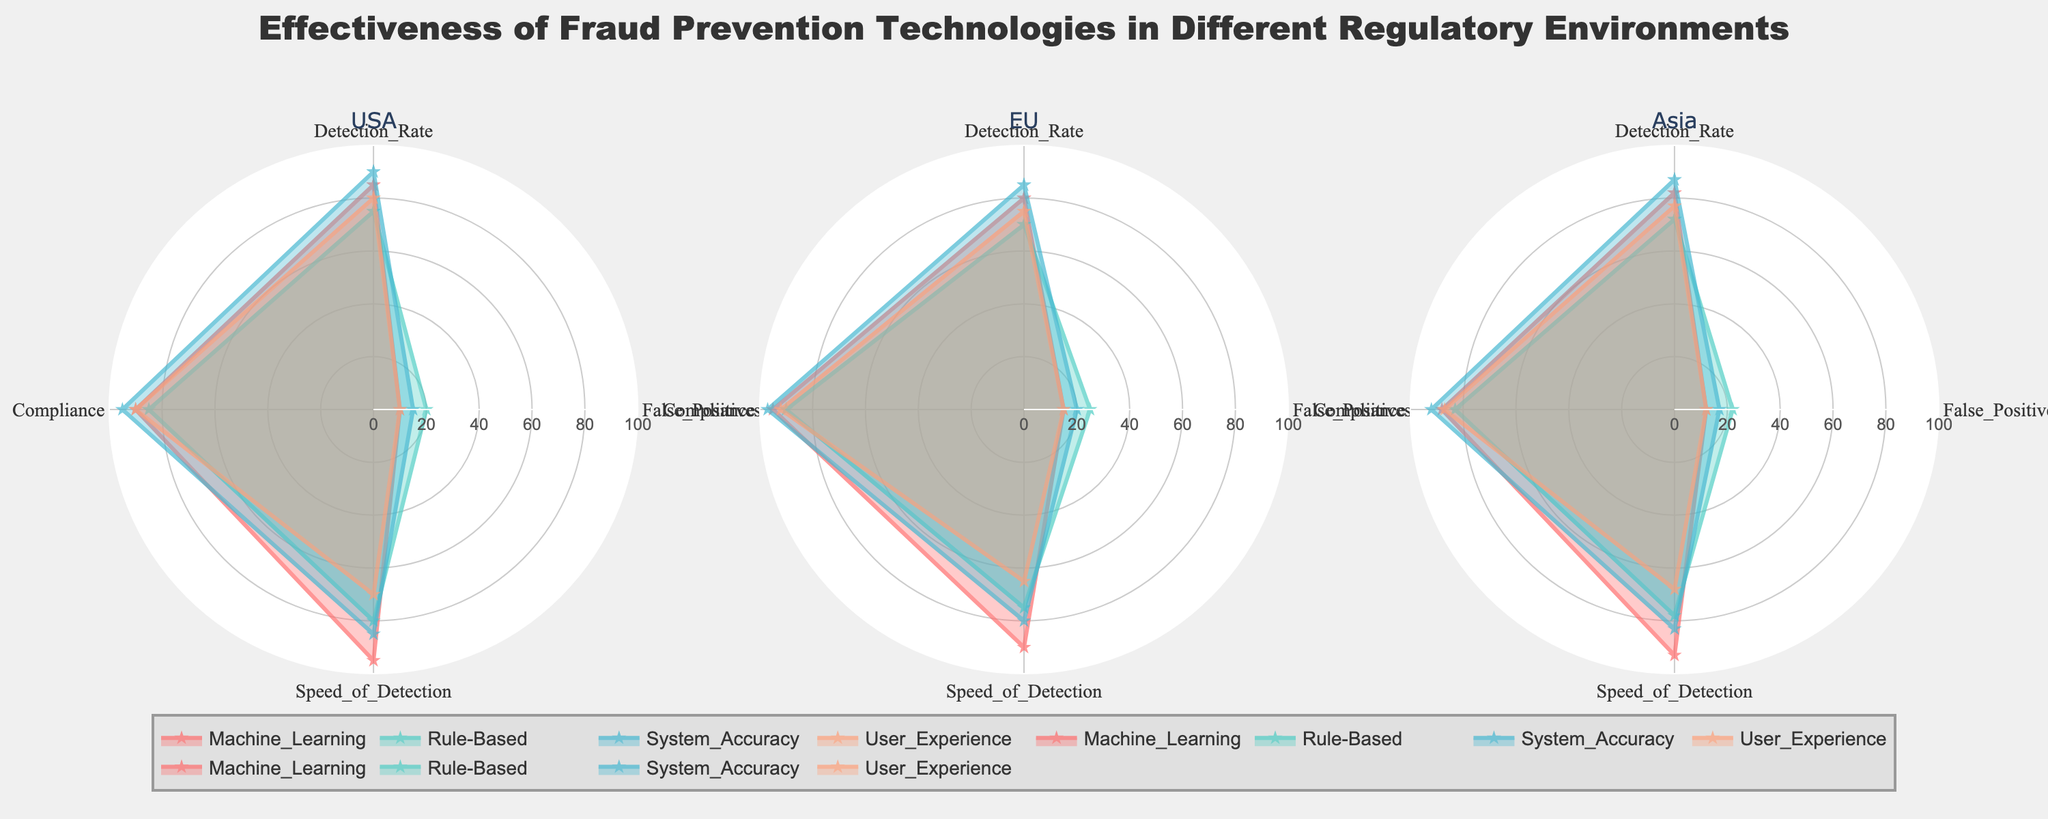What is the title of the plot? The title is displayed at the top of the plot and reads "Effectiveness of Fraud Prevention Technologies in Different Regulatory Environments".
Answer: Effectiveness of Fraud Prevention Technologies in Different Regulatory Environments How many subplots are in the figure, and what do they represent? The figure contains three subplots, each representing a different regulatory environment: USA, EU, and Asia.
Answer: Three subplots (USA, EU, Asia) Which regulatory environment has the highest detection rate for Machine Learning? Look at the detection rate for Machine Learning in all three regulatory environments. The USA has a detection rate of 85, EU has 80, and Asia has 82; thus, the USA has the highest detection rate for Machine Learning.
Answer: USA For the EU regulatory environment, what is the false positive rate for Rule-Based fraud prevention technology? In the EU subplot, the radar chart for the Rule-Based technology shows a false positive rate of 25.
Answer: 25 Which technology has the best user experience in the USA regulatory environment? In the USA subplot, compare the user experience scores of all technologies. The highest user experience score is 90 for the System_Accuracy technology.
Answer: System_Accuracy In which regulatory environment is the speed of detection for User Experience the lowest? Compare the speed of detection scores for User Experience across all three regulatory environments: 70 (USA), 65 (EU), 68 (Asia). The lowest speed of detection score is 65 in the EU.
Answer: EU Which two regulatory environments have identical compliance scores for User Experience? Compare the compliance scores for User Experience across all three environments. Both the USA and the EU have a compliance score of 90 for User Experience.
Answer: USA and EU What is the average detection rate for the Rule-Based technology across all regulatory environments? Calculate the average detection rate for Rule-Based technology: (75 + 70 + 72) / 3 = 72.33.
Answer: 72.33 In the Asia regulatory environment, which technology has the highest false positive rate, and what is the value? Look at the false positive rates in the Asia subplot. Rule-Based technology has the highest false positive rate of 22.
Answer: Rule-Based, 22 Which fraud prevention technology shows the fastest speed of detection in the EU regulatory environment? In the EU subplot, compare the speed of detection scores. Machine_Learning has the highest speed of detection at 90.
Answer: Machine_Learning 